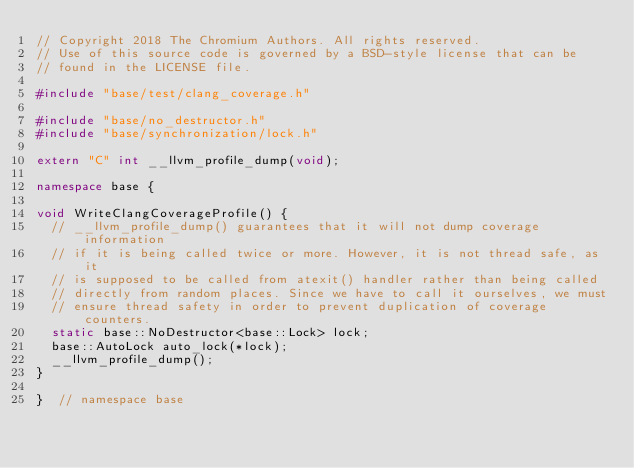Convert code to text. <code><loc_0><loc_0><loc_500><loc_500><_C++_>// Copyright 2018 The Chromium Authors. All rights reserved.
// Use of this source code is governed by a BSD-style license that can be
// found in the LICENSE file.

#include "base/test/clang_coverage.h"

#include "base/no_destructor.h"
#include "base/synchronization/lock.h"

extern "C" int __llvm_profile_dump(void);

namespace base {

void WriteClangCoverageProfile() {
  // __llvm_profile_dump() guarantees that it will not dump coverage information
  // if it is being called twice or more. However, it is not thread safe, as it
  // is supposed to be called from atexit() handler rather than being called
  // directly from random places. Since we have to call it ourselves, we must
  // ensure thread safety in order to prevent duplication of coverage counters.
  static base::NoDestructor<base::Lock> lock;
  base::AutoLock auto_lock(*lock);
  __llvm_profile_dump();
}

}  // namespace base
</code> 